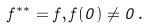<formula> <loc_0><loc_0><loc_500><loc_500>f ^ { * * } = f , f ( 0 ) \neq 0 \, .</formula> 